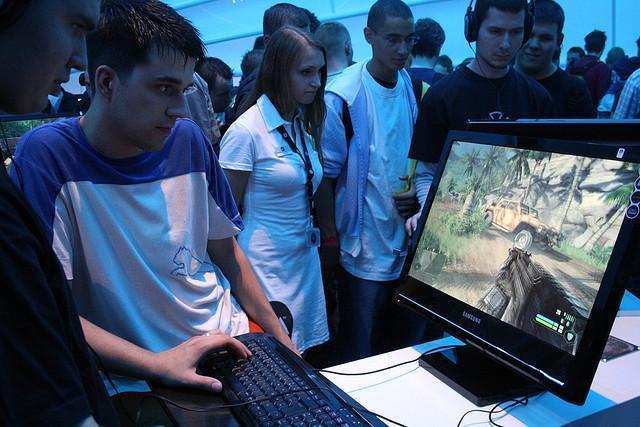How many trucks are there?
Give a very brief answer. 1. How many tvs are there?
Give a very brief answer. 2. How many people are in the photo?
Give a very brief answer. 7. 